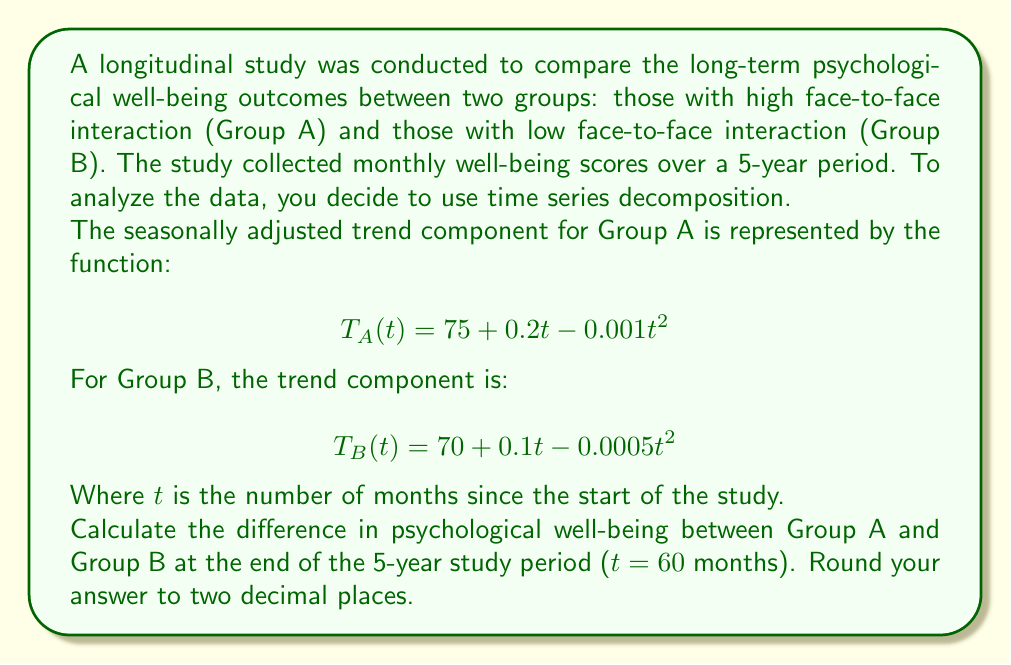Give your solution to this math problem. To solve this problem, we need to follow these steps:

1. Evaluate the trend component for Group A at t = 60 months:
   $$T_A(60) = 75 + 0.2(60) - 0.001(60)^2$$
   $$= 75 + 12 - 0.001(3600)$$
   $$= 75 + 12 - 3.6$$
   $$= 83.4$$

2. Evaluate the trend component for Group B at t = 60 months:
   $$T_B(60) = 70 + 0.1(60) - 0.0005(60)^2$$
   $$= 70 + 6 - 0.0005(3600)$$
   $$= 70 + 6 - 1.8$$
   $$= 74.2$$

3. Calculate the difference between Group A and Group B:
   $$\text{Difference} = T_A(60) - T_B(60)$$
   $$= 83.4 - 74.2$$
   $$= 9.2$$

The difference in psychological well-being between Group A (high face-to-face interaction) and Group B (low face-to-face interaction) at the end of the 5-year study period is 9.2 points.

This result suggests that individuals with high face-to-face interaction (Group A) have a higher level of psychological well-being compared to those with low face-to-face interaction (Group B) after 5 years, supporting the importance of face-to-face communication and bonding for long-term psychological well-being.
Answer: 9.2 